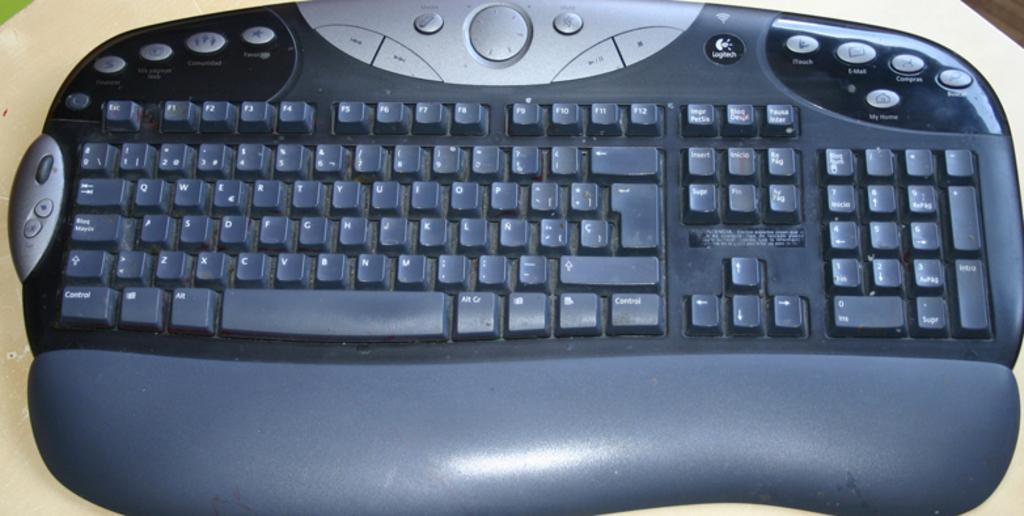What is the color of the surface in the image? The image shows a cream-colored surface. What object is placed on the surface? There is a keyboard on the surface. What are the colors of the keyboard? The keyboard is black and ash in color. How many pizzas are being prepared on the keyboard in the image? There are no pizzas present in the image, as it features a keyboard on a cream-colored surface. 